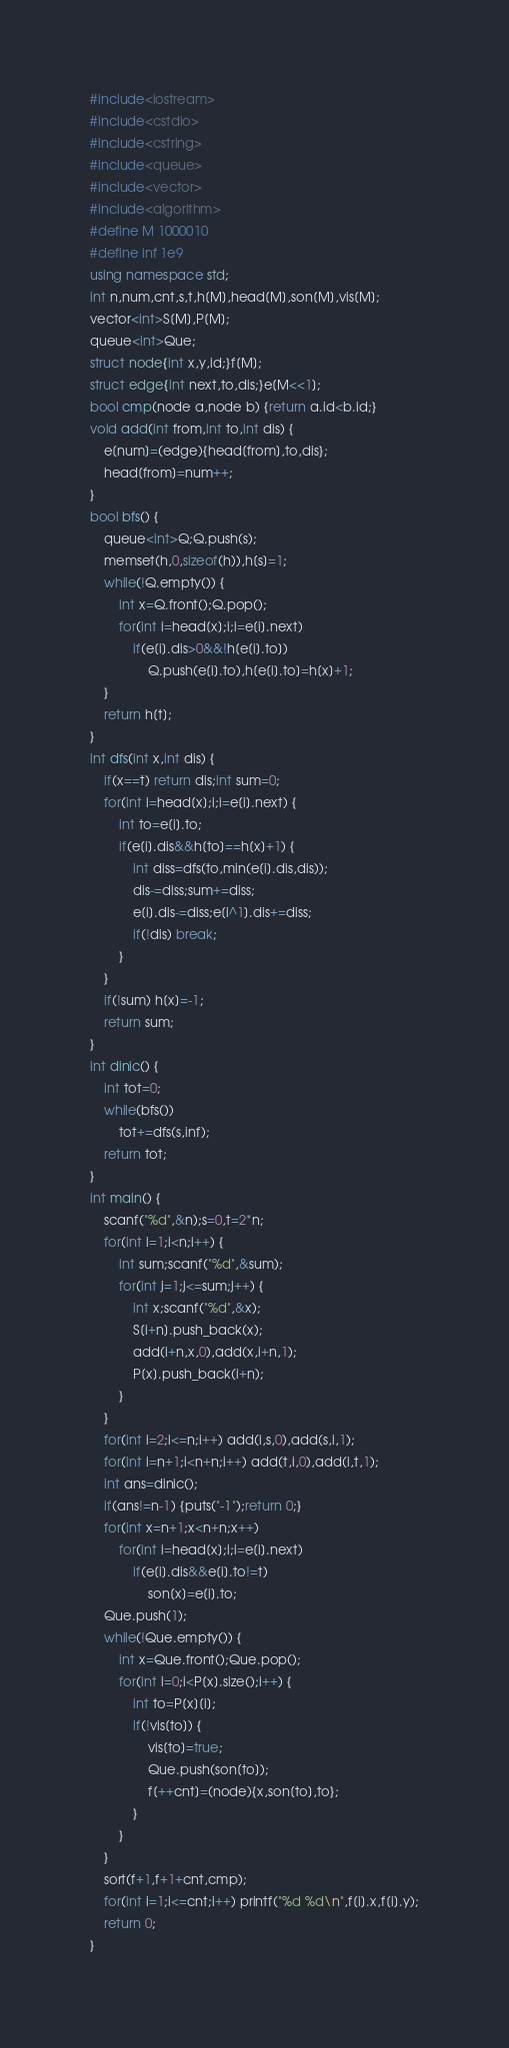Convert code to text. <code><loc_0><loc_0><loc_500><loc_500><_C++_>#include<iostream>
#include<cstdio>
#include<cstring>
#include<queue>
#include<vector>
#include<algorithm>
#define M 1000010
#define inf 1e9
using namespace std;
int n,num,cnt,s,t,h[M],head[M],son[M],vis[M];
vector<int>S[M],P[M];
queue<int>Que;
struct node{int x,y,id;}f[M];
struct edge{int next,to,dis;}e[M<<1];
bool cmp(node a,node b) {return a.id<b.id;}
void add(int from,int to,int dis) {
	e[num]=(edge){head[from],to,dis};
	head[from]=num++;
}
bool bfs() {
	queue<int>Q;Q.push(s);
	memset(h,0,sizeof(h)),h[s]=1;
	while(!Q.empty()) {
		int x=Q.front();Q.pop();
		for(int i=head[x];i;i=e[i].next)
			if(e[i].dis>0&&!h[e[i].to])
				Q.push(e[i].to),h[e[i].to]=h[x]+1;
	}
	return h[t];
}
int dfs(int x,int dis) {
	if(x==t) return dis;int sum=0;
	for(int i=head[x];i;i=e[i].next) {
		int to=e[i].to;
		if(e[i].dis&&h[to]==h[x]+1) {
			int diss=dfs(to,min(e[i].dis,dis));
			dis-=diss;sum+=diss;
			e[i].dis-=diss;e[i^1].dis+=diss;
			if(!dis) break;
		}
	}
	if(!sum) h[x]=-1;
	return sum;
}
int dinic() {
	int tot=0;
	while(bfs()) 
		tot+=dfs(s,inf);
	return tot;
}
int main() {
	scanf("%d",&n);s=0,t=2*n;
	for(int i=1;i<n;i++) {
		int sum;scanf("%d",&sum);
		for(int j=1;j<=sum;j++) {
			int x;scanf("%d",&x);
			S[i+n].push_back(x);
			add(i+n,x,0),add(x,i+n,1);
			P[x].push_back(i+n);
		}
	}
	for(int i=2;i<=n;i++) add(i,s,0),add(s,i,1);
	for(int i=n+1;i<n+n;i++) add(t,i,0),add(i,t,1);
	int ans=dinic();
	if(ans!=n-1) {puts("-1");return 0;}
	for(int x=n+1;x<n+n;x++)
		for(int i=head[x];i;i=e[i].next)
			if(e[i].dis&&e[i].to!=t)
				son[x]=e[i].to;
	Que.push(1);
	while(!Que.empty()) {
		int x=Que.front();Que.pop();
		for(int i=0;i<P[x].size();i++) {
			int to=P[x][i];
			if(!vis[to]) {
				vis[to]=true;
				Que.push(son[to]);
				f[++cnt]=(node){x,son[to],to};
			}
		}
	}
	sort(f+1,f+1+cnt,cmp);
	for(int i=1;i<=cnt;i++) printf("%d %d\n",f[i].x,f[i].y);
	return 0;
}</code> 